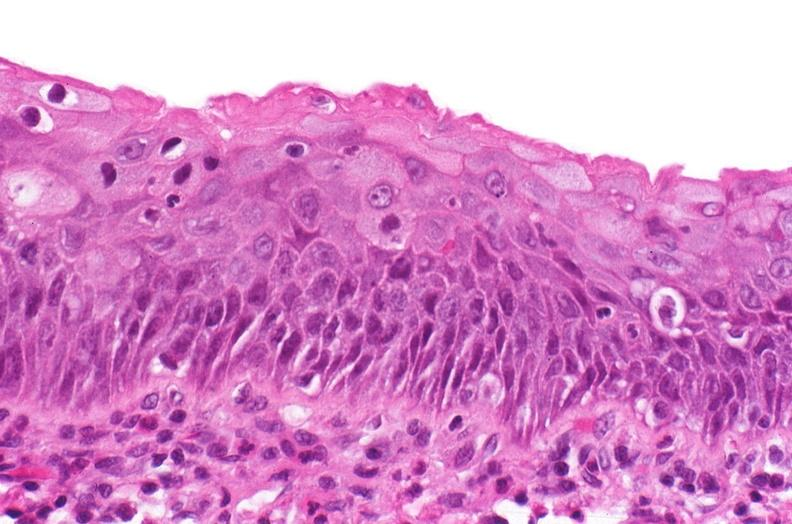does this image show renal pelvis, squamous metaplasia due to chronic urolithiasis?
Answer the question using a single word or phrase. Yes 